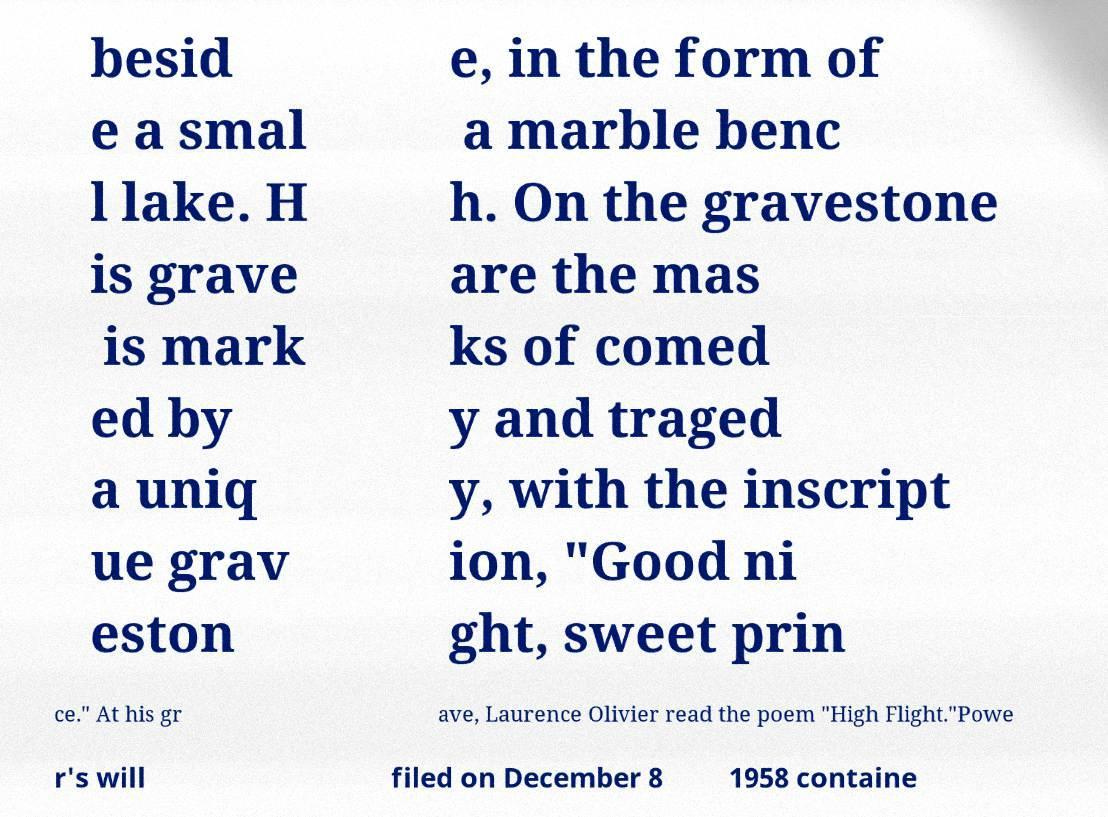Can you read and provide the text displayed in the image?This photo seems to have some interesting text. Can you extract and type it out for me? besid e a smal l lake. H is grave is mark ed by a uniq ue grav eston e, in the form of a marble benc h. On the gravestone are the mas ks of comed y and traged y, with the inscript ion, "Good ni ght, sweet prin ce." At his gr ave, Laurence Olivier read the poem "High Flight."Powe r's will filed on December 8 1958 containe 